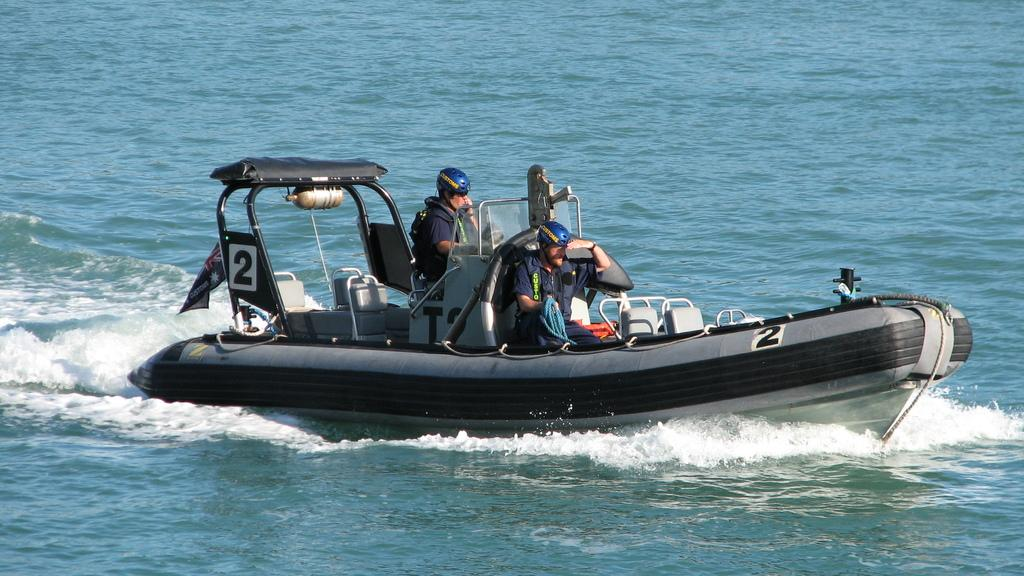How many people are in the image? There are two people in the image. What are the people doing in the image? The people are sitting in a boat. What are the people wearing while in the boat? The people are wearing helmets. Where is the boat located in the image? The boat is on the water. What type of hose can be seen connected to the truck in the image? There is no truck or hose present in the image; it features two people sitting in a boat on the water. 